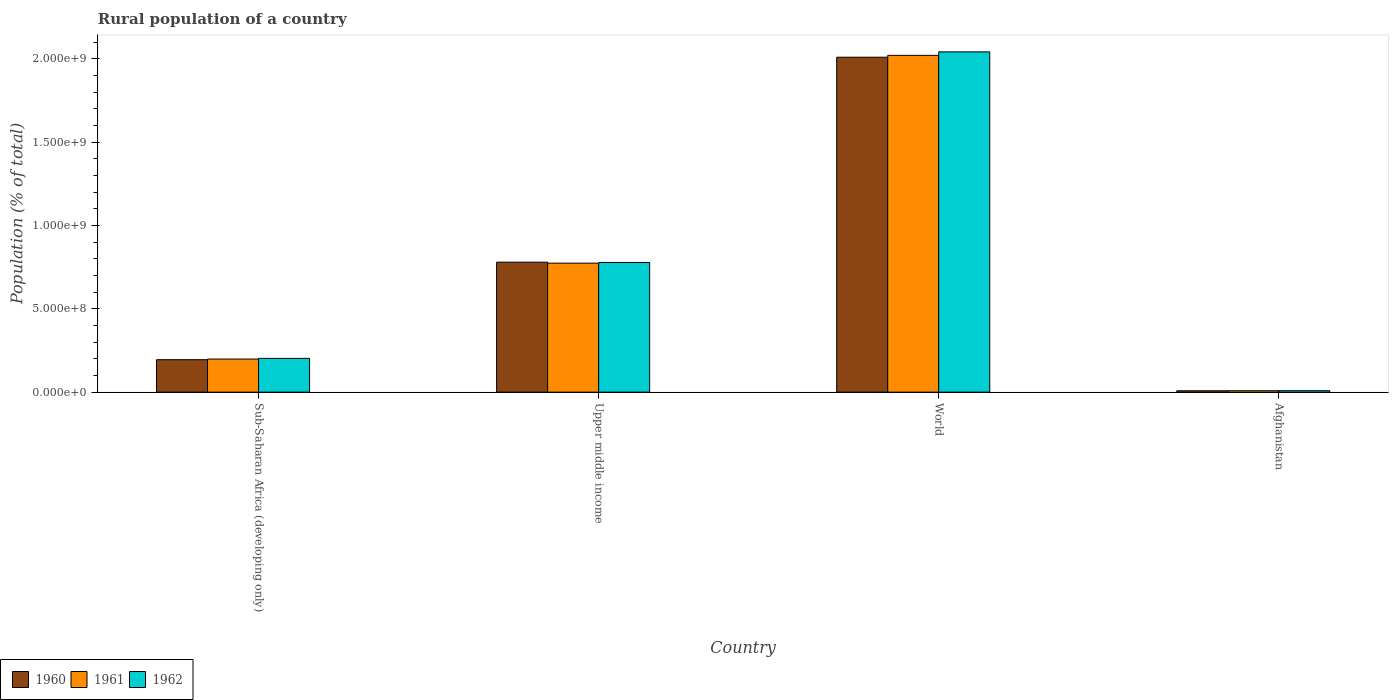How many different coloured bars are there?
Give a very brief answer. 3. Are the number of bars on each tick of the X-axis equal?
Keep it short and to the point. Yes. How many bars are there on the 3rd tick from the right?
Ensure brevity in your answer.  3. What is the label of the 4th group of bars from the left?
Give a very brief answer. Afghanistan. What is the rural population in 1961 in Afghanistan?
Make the answer very short. 8.39e+06. Across all countries, what is the maximum rural population in 1960?
Offer a very short reply. 2.01e+09. Across all countries, what is the minimum rural population in 1960?
Provide a succinct answer. 8.26e+06. In which country was the rural population in 1962 maximum?
Make the answer very short. World. In which country was the rural population in 1962 minimum?
Your answer should be compact. Afghanistan. What is the total rural population in 1962 in the graph?
Keep it short and to the point. 3.03e+09. What is the difference between the rural population in 1960 in Afghanistan and that in Upper middle income?
Give a very brief answer. -7.71e+08. What is the difference between the rural population in 1961 in Upper middle income and the rural population in 1960 in Afghanistan?
Ensure brevity in your answer.  7.65e+08. What is the average rural population in 1962 per country?
Keep it short and to the point. 7.57e+08. What is the difference between the rural population of/in 1960 and rural population of/in 1961 in Sub-Saharan Africa (developing only)?
Your answer should be very brief. -3.95e+06. What is the ratio of the rural population in 1962 in Upper middle income to that in World?
Give a very brief answer. 0.38. Is the rural population in 1962 in Afghanistan less than that in World?
Ensure brevity in your answer.  Yes. What is the difference between the highest and the second highest rural population in 1961?
Your answer should be very brief. -1.25e+09. What is the difference between the highest and the lowest rural population in 1962?
Your answer should be compact. 2.03e+09. Is the sum of the rural population in 1962 in Sub-Saharan Africa (developing only) and Upper middle income greater than the maximum rural population in 1960 across all countries?
Keep it short and to the point. No. What does the 2nd bar from the left in Upper middle income represents?
Provide a short and direct response. 1961. What does the 3rd bar from the right in Upper middle income represents?
Provide a short and direct response. 1960. Are all the bars in the graph horizontal?
Your response must be concise. No. How many countries are there in the graph?
Your answer should be compact. 4. Does the graph contain any zero values?
Give a very brief answer. No. Where does the legend appear in the graph?
Your answer should be compact. Bottom left. How many legend labels are there?
Your response must be concise. 3. What is the title of the graph?
Make the answer very short. Rural population of a country. Does "1968" appear as one of the legend labels in the graph?
Offer a very short reply. No. What is the label or title of the X-axis?
Make the answer very short. Country. What is the label or title of the Y-axis?
Your answer should be very brief. Population (% of total). What is the Population (% of total) of 1960 in Sub-Saharan Africa (developing only)?
Give a very brief answer. 1.95e+08. What is the Population (% of total) of 1961 in Sub-Saharan Africa (developing only)?
Provide a short and direct response. 1.99e+08. What is the Population (% of total) in 1962 in Sub-Saharan Africa (developing only)?
Keep it short and to the point. 2.03e+08. What is the Population (% of total) in 1960 in Upper middle income?
Your response must be concise. 7.80e+08. What is the Population (% of total) of 1961 in Upper middle income?
Keep it short and to the point. 7.74e+08. What is the Population (% of total) in 1962 in Upper middle income?
Ensure brevity in your answer.  7.78e+08. What is the Population (% of total) of 1960 in World?
Your response must be concise. 2.01e+09. What is the Population (% of total) in 1961 in World?
Provide a short and direct response. 2.02e+09. What is the Population (% of total) in 1962 in World?
Provide a succinct answer. 2.04e+09. What is the Population (% of total) of 1960 in Afghanistan?
Provide a succinct answer. 8.26e+06. What is the Population (% of total) in 1961 in Afghanistan?
Offer a terse response. 8.39e+06. What is the Population (% of total) in 1962 in Afghanistan?
Provide a succinct answer. 8.52e+06. Across all countries, what is the maximum Population (% of total) in 1960?
Offer a very short reply. 2.01e+09. Across all countries, what is the maximum Population (% of total) in 1961?
Make the answer very short. 2.02e+09. Across all countries, what is the maximum Population (% of total) of 1962?
Ensure brevity in your answer.  2.04e+09. Across all countries, what is the minimum Population (% of total) of 1960?
Your answer should be compact. 8.26e+06. Across all countries, what is the minimum Population (% of total) in 1961?
Your answer should be compact. 8.39e+06. Across all countries, what is the minimum Population (% of total) of 1962?
Offer a very short reply. 8.52e+06. What is the total Population (% of total) in 1960 in the graph?
Make the answer very short. 2.99e+09. What is the total Population (% of total) of 1961 in the graph?
Ensure brevity in your answer.  3.00e+09. What is the total Population (% of total) in 1962 in the graph?
Provide a succinct answer. 3.03e+09. What is the difference between the Population (% of total) of 1960 in Sub-Saharan Africa (developing only) and that in Upper middle income?
Provide a short and direct response. -5.85e+08. What is the difference between the Population (% of total) in 1961 in Sub-Saharan Africa (developing only) and that in Upper middle income?
Ensure brevity in your answer.  -5.75e+08. What is the difference between the Population (% of total) in 1962 in Sub-Saharan Africa (developing only) and that in Upper middle income?
Your answer should be compact. -5.75e+08. What is the difference between the Population (% of total) of 1960 in Sub-Saharan Africa (developing only) and that in World?
Keep it short and to the point. -1.81e+09. What is the difference between the Population (% of total) of 1961 in Sub-Saharan Africa (developing only) and that in World?
Offer a terse response. -1.82e+09. What is the difference between the Population (% of total) in 1962 in Sub-Saharan Africa (developing only) and that in World?
Your answer should be very brief. -1.84e+09. What is the difference between the Population (% of total) in 1960 in Sub-Saharan Africa (developing only) and that in Afghanistan?
Offer a terse response. 1.86e+08. What is the difference between the Population (% of total) of 1961 in Sub-Saharan Africa (developing only) and that in Afghanistan?
Your answer should be compact. 1.90e+08. What is the difference between the Population (% of total) in 1962 in Sub-Saharan Africa (developing only) and that in Afghanistan?
Make the answer very short. 1.94e+08. What is the difference between the Population (% of total) in 1960 in Upper middle income and that in World?
Ensure brevity in your answer.  -1.23e+09. What is the difference between the Population (% of total) in 1961 in Upper middle income and that in World?
Your answer should be compact. -1.25e+09. What is the difference between the Population (% of total) in 1962 in Upper middle income and that in World?
Provide a succinct answer. -1.26e+09. What is the difference between the Population (% of total) in 1960 in Upper middle income and that in Afghanistan?
Provide a succinct answer. 7.71e+08. What is the difference between the Population (% of total) in 1961 in Upper middle income and that in Afghanistan?
Your answer should be very brief. 7.65e+08. What is the difference between the Population (% of total) of 1962 in Upper middle income and that in Afghanistan?
Offer a very short reply. 7.69e+08. What is the difference between the Population (% of total) of 1960 in World and that in Afghanistan?
Give a very brief answer. 2.00e+09. What is the difference between the Population (% of total) of 1961 in World and that in Afghanistan?
Offer a terse response. 2.01e+09. What is the difference between the Population (% of total) of 1962 in World and that in Afghanistan?
Make the answer very short. 2.03e+09. What is the difference between the Population (% of total) of 1960 in Sub-Saharan Africa (developing only) and the Population (% of total) of 1961 in Upper middle income?
Ensure brevity in your answer.  -5.79e+08. What is the difference between the Population (% of total) in 1960 in Sub-Saharan Africa (developing only) and the Population (% of total) in 1962 in Upper middle income?
Your answer should be compact. -5.83e+08. What is the difference between the Population (% of total) of 1961 in Sub-Saharan Africa (developing only) and the Population (% of total) of 1962 in Upper middle income?
Provide a short and direct response. -5.79e+08. What is the difference between the Population (% of total) of 1960 in Sub-Saharan Africa (developing only) and the Population (% of total) of 1961 in World?
Provide a succinct answer. -1.83e+09. What is the difference between the Population (% of total) in 1960 in Sub-Saharan Africa (developing only) and the Population (% of total) in 1962 in World?
Your answer should be compact. -1.85e+09. What is the difference between the Population (% of total) of 1961 in Sub-Saharan Africa (developing only) and the Population (% of total) of 1962 in World?
Your response must be concise. -1.84e+09. What is the difference between the Population (% of total) of 1960 in Sub-Saharan Africa (developing only) and the Population (% of total) of 1961 in Afghanistan?
Make the answer very short. 1.86e+08. What is the difference between the Population (% of total) in 1960 in Sub-Saharan Africa (developing only) and the Population (% of total) in 1962 in Afghanistan?
Provide a succinct answer. 1.86e+08. What is the difference between the Population (% of total) of 1961 in Sub-Saharan Africa (developing only) and the Population (% of total) of 1962 in Afghanistan?
Provide a short and direct response. 1.90e+08. What is the difference between the Population (% of total) of 1960 in Upper middle income and the Population (% of total) of 1961 in World?
Offer a terse response. -1.24e+09. What is the difference between the Population (% of total) in 1960 in Upper middle income and the Population (% of total) in 1962 in World?
Your answer should be compact. -1.26e+09. What is the difference between the Population (% of total) in 1961 in Upper middle income and the Population (% of total) in 1962 in World?
Offer a terse response. -1.27e+09. What is the difference between the Population (% of total) of 1960 in Upper middle income and the Population (% of total) of 1961 in Afghanistan?
Provide a short and direct response. 7.71e+08. What is the difference between the Population (% of total) of 1960 in Upper middle income and the Population (% of total) of 1962 in Afghanistan?
Your answer should be very brief. 7.71e+08. What is the difference between the Population (% of total) in 1961 in Upper middle income and the Population (% of total) in 1962 in Afghanistan?
Make the answer very short. 7.65e+08. What is the difference between the Population (% of total) in 1960 in World and the Population (% of total) in 1961 in Afghanistan?
Provide a short and direct response. 2.00e+09. What is the difference between the Population (% of total) in 1960 in World and the Population (% of total) in 1962 in Afghanistan?
Provide a succinct answer. 2.00e+09. What is the difference between the Population (% of total) in 1961 in World and the Population (% of total) in 1962 in Afghanistan?
Offer a terse response. 2.01e+09. What is the average Population (% of total) of 1960 per country?
Make the answer very short. 7.48e+08. What is the average Population (% of total) in 1961 per country?
Your answer should be compact. 7.50e+08. What is the average Population (% of total) of 1962 per country?
Offer a very short reply. 7.57e+08. What is the difference between the Population (% of total) in 1960 and Population (% of total) in 1961 in Sub-Saharan Africa (developing only)?
Keep it short and to the point. -3.95e+06. What is the difference between the Population (% of total) of 1960 and Population (% of total) of 1962 in Sub-Saharan Africa (developing only)?
Keep it short and to the point. -8.00e+06. What is the difference between the Population (% of total) in 1961 and Population (% of total) in 1962 in Sub-Saharan Africa (developing only)?
Make the answer very short. -4.05e+06. What is the difference between the Population (% of total) of 1960 and Population (% of total) of 1961 in Upper middle income?
Your answer should be compact. 5.94e+06. What is the difference between the Population (% of total) in 1960 and Population (% of total) in 1962 in Upper middle income?
Your response must be concise. 1.89e+06. What is the difference between the Population (% of total) in 1961 and Population (% of total) in 1962 in Upper middle income?
Give a very brief answer. -4.04e+06. What is the difference between the Population (% of total) in 1960 and Population (% of total) in 1961 in World?
Make the answer very short. -1.12e+07. What is the difference between the Population (% of total) of 1960 and Population (% of total) of 1962 in World?
Provide a short and direct response. -3.20e+07. What is the difference between the Population (% of total) in 1961 and Population (% of total) in 1962 in World?
Keep it short and to the point. -2.08e+07. What is the difference between the Population (% of total) in 1960 and Population (% of total) in 1961 in Afghanistan?
Offer a very short reply. -1.30e+05. What is the difference between the Population (% of total) of 1960 and Population (% of total) of 1962 in Afghanistan?
Offer a very short reply. -2.66e+05. What is the difference between the Population (% of total) of 1961 and Population (% of total) of 1962 in Afghanistan?
Your answer should be very brief. -1.36e+05. What is the ratio of the Population (% of total) of 1960 in Sub-Saharan Africa (developing only) to that in Upper middle income?
Your answer should be very brief. 0.25. What is the ratio of the Population (% of total) of 1961 in Sub-Saharan Africa (developing only) to that in Upper middle income?
Provide a short and direct response. 0.26. What is the ratio of the Population (% of total) in 1962 in Sub-Saharan Africa (developing only) to that in Upper middle income?
Your answer should be compact. 0.26. What is the ratio of the Population (% of total) of 1960 in Sub-Saharan Africa (developing only) to that in World?
Provide a short and direct response. 0.1. What is the ratio of the Population (% of total) of 1961 in Sub-Saharan Africa (developing only) to that in World?
Provide a short and direct response. 0.1. What is the ratio of the Population (% of total) of 1962 in Sub-Saharan Africa (developing only) to that in World?
Your answer should be very brief. 0.1. What is the ratio of the Population (% of total) of 1960 in Sub-Saharan Africa (developing only) to that in Afghanistan?
Your answer should be compact. 23.58. What is the ratio of the Population (% of total) of 1961 in Sub-Saharan Africa (developing only) to that in Afghanistan?
Your answer should be compact. 23.68. What is the ratio of the Population (% of total) of 1962 in Sub-Saharan Africa (developing only) to that in Afghanistan?
Provide a succinct answer. 23.78. What is the ratio of the Population (% of total) of 1960 in Upper middle income to that in World?
Your answer should be compact. 0.39. What is the ratio of the Population (% of total) in 1961 in Upper middle income to that in World?
Your response must be concise. 0.38. What is the ratio of the Population (% of total) in 1962 in Upper middle income to that in World?
Offer a terse response. 0.38. What is the ratio of the Population (% of total) of 1960 in Upper middle income to that in Afghanistan?
Give a very brief answer. 94.44. What is the ratio of the Population (% of total) of 1961 in Upper middle income to that in Afghanistan?
Your response must be concise. 92.27. What is the ratio of the Population (% of total) in 1962 in Upper middle income to that in Afghanistan?
Provide a succinct answer. 91.27. What is the ratio of the Population (% of total) of 1960 in World to that in Afghanistan?
Offer a terse response. 243.34. What is the ratio of the Population (% of total) of 1961 in World to that in Afghanistan?
Provide a short and direct response. 240.9. What is the ratio of the Population (% of total) in 1962 in World to that in Afghanistan?
Ensure brevity in your answer.  239.5. What is the difference between the highest and the second highest Population (% of total) of 1960?
Provide a succinct answer. 1.23e+09. What is the difference between the highest and the second highest Population (% of total) of 1961?
Offer a terse response. 1.25e+09. What is the difference between the highest and the second highest Population (% of total) in 1962?
Keep it short and to the point. 1.26e+09. What is the difference between the highest and the lowest Population (% of total) of 1960?
Keep it short and to the point. 2.00e+09. What is the difference between the highest and the lowest Population (% of total) of 1961?
Keep it short and to the point. 2.01e+09. What is the difference between the highest and the lowest Population (% of total) in 1962?
Your answer should be compact. 2.03e+09. 